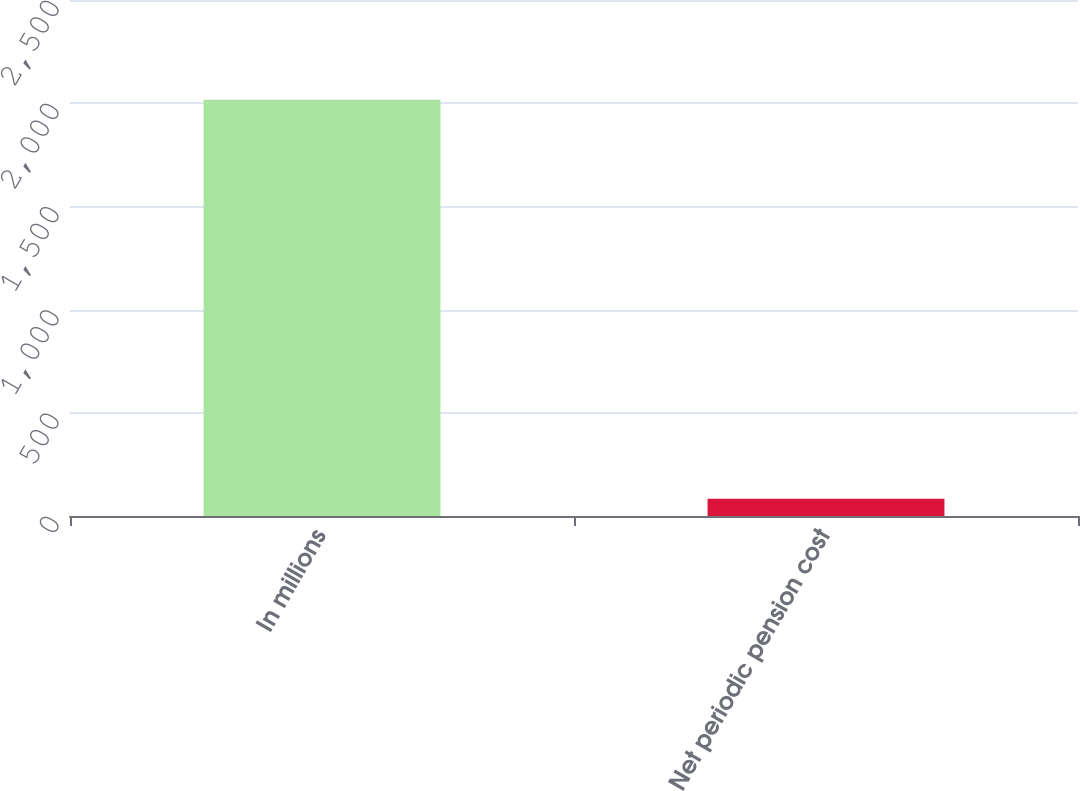<chart> <loc_0><loc_0><loc_500><loc_500><bar_chart><fcel>In millions<fcel>Net periodic pension cost<nl><fcel>2017<fcel>83<nl></chart> 